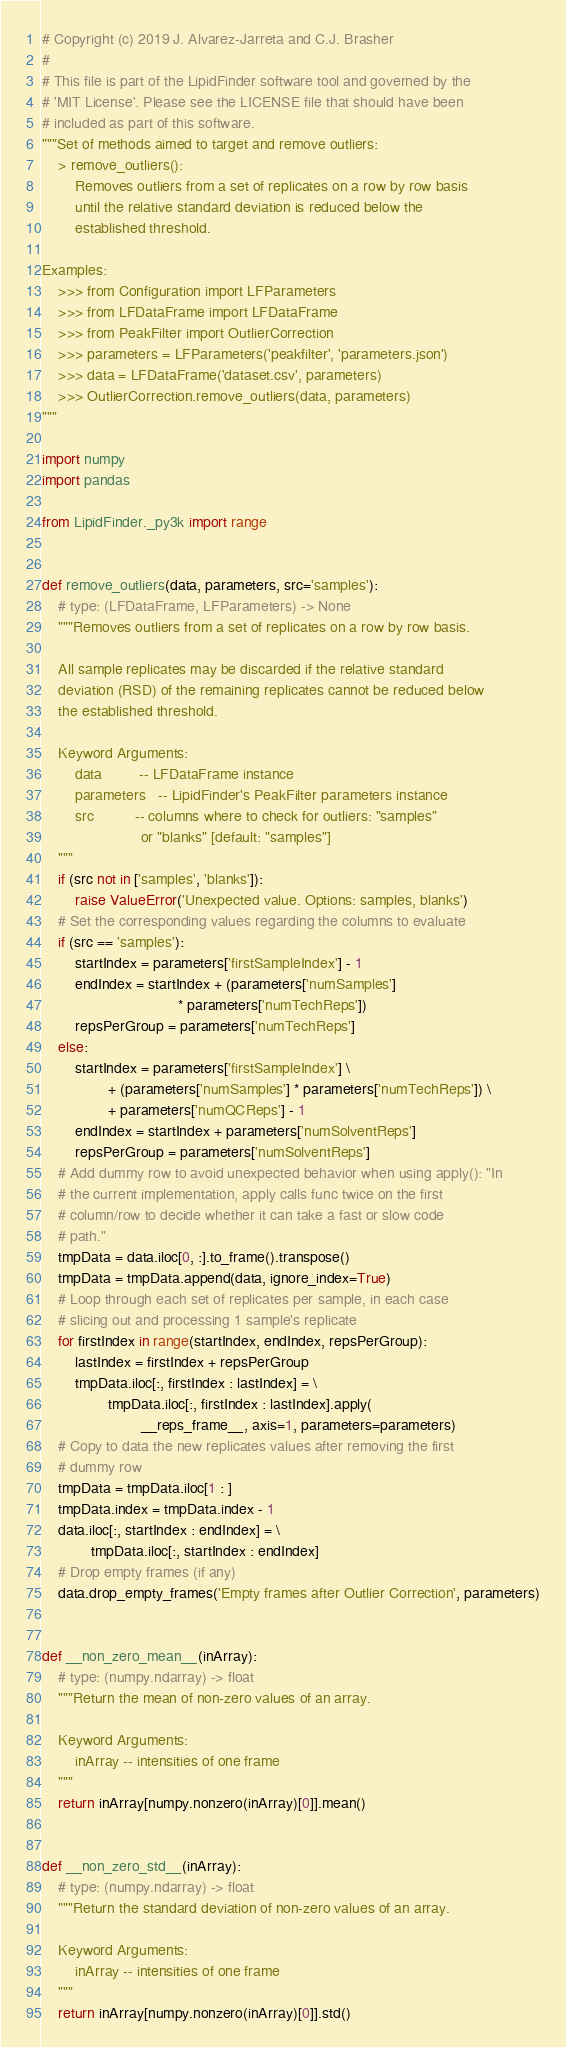Convert code to text. <code><loc_0><loc_0><loc_500><loc_500><_Python_># Copyright (c) 2019 J. Alvarez-Jarreta and C.J. Brasher
#
# This file is part of the LipidFinder software tool and governed by the
# 'MIT License'. Please see the LICENSE file that should have been
# included as part of this software.
"""Set of methods aimed to target and remove outliers:
    > remove_outliers():
        Removes outliers from a set of replicates on a row by row basis
        until the relative standard deviation is reduced below the
        established threshold.

Examples:
    >>> from Configuration import LFParameters
    >>> from LFDataFrame import LFDataFrame
    >>> from PeakFilter import OutlierCorrection
    >>> parameters = LFParameters('peakfilter', 'parameters.json')
    >>> data = LFDataFrame('dataset.csv', parameters)
    >>> OutlierCorrection.remove_outliers(data, parameters)
"""

import numpy
import pandas

from LipidFinder._py3k import range


def remove_outliers(data, parameters, src='samples'):
    # type: (LFDataFrame, LFParameters) -> None
    """Removes outliers from a set of replicates on a row by row basis.

    All sample replicates may be discarded if the relative standard
    deviation (RSD) of the remaining replicates cannot be reduced below
    the established threshold.

    Keyword Arguments:
        data         -- LFDataFrame instance
        parameters   -- LipidFinder's PeakFilter parameters instance
        src          -- columns where to check for outliers: "samples"
                        or "blanks" [default: "samples"]
    """
    if (src not in ['samples', 'blanks']):
        raise ValueError('Unexpected value. Options: samples, blanks')
    # Set the corresponding values regarding the columns to evaluate
    if (src == 'samples'):
        startIndex = parameters['firstSampleIndex'] - 1
        endIndex = startIndex + (parameters['numSamples']
                                 * parameters['numTechReps'])
        repsPerGroup = parameters['numTechReps']
    else:
        startIndex = parameters['firstSampleIndex'] \
                + (parameters['numSamples'] * parameters['numTechReps']) \
                + parameters['numQCReps'] - 1
        endIndex = startIndex + parameters['numSolventReps']
        repsPerGroup = parameters['numSolventReps']
    # Add dummy row to avoid unexpected behavior when using apply(): "In
    # the current implementation, apply calls func twice on the first
    # column/row to decide whether it can take a fast or slow code
    # path."
    tmpData = data.iloc[0, :].to_frame().transpose()
    tmpData = tmpData.append(data, ignore_index=True)
    # Loop through each set of replicates per sample, in each case
    # slicing out and processing 1 sample's replicate
    for firstIndex in range(startIndex, endIndex, repsPerGroup):
        lastIndex = firstIndex + repsPerGroup
        tmpData.iloc[:, firstIndex : lastIndex] = \
                tmpData.iloc[:, firstIndex : lastIndex].apply(
                        __reps_frame__, axis=1, parameters=parameters)
    # Copy to data the new replicates values after removing the first
    # dummy row
    tmpData = tmpData.iloc[1 : ]
    tmpData.index = tmpData.index - 1
    data.iloc[:, startIndex : endIndex] = \
            tmpData.iloc[:, startIndex : endIndex]
    # Drop empty frames (if any)
    data.drop_empty_frames('Empty frames after Outlier Correction', parameters)


def __non_zero_mean__(inArray):
    # type: (numpy.ndarray) -> float
    """Return the mean of non-zero values of an array.

    Keyword Arguments:
        inArray -- intensities of one frame
    """
    return inArray[numpy.nonzero(inArray)[0]].mean()


def __non_zero_std__(inArray):
    # type: (numpy.ndarray) -> float
    """Return the standard deviation of non-zero values of an array.

    Keyword Arguments:
        inArray -- intensities of one frame
    """
    return inArray[numpy.nonzero(inArray)[0]].std()

</code> 